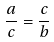Convert formula to latex. <formula><loc_0><loc_0><loc_500><loc_500>\frac { a } { c } = \frac { c } { b }</formula> 